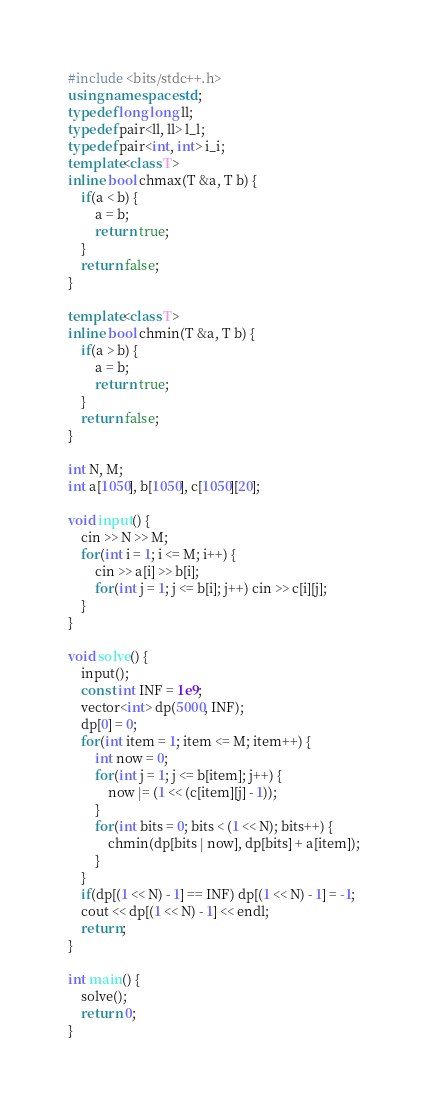Convert code to text. <code><loc_0><loc_0><loc_500><loc_500><_C++_>#include <bits/stdc++.h>
using namespace std;
typedef long long ll;
typedef pair<ll, ll> l_l;
typedef pair<int, int> i_i;
template<class T>
inline bool chmax(T &a, T b) {
    if(a < b) {
        a = b;
        return true;
    }
    return false;
}

template<class T>
inline bool chmin(T &a, T b) {
    if(a > b) {
        a = b;
        return true;
    }
    return false;
}

int N, M;
int a[1050], b[1050], c[1050][20];

void input() {
    cin >> N >> M;
    for(int i = 1; i <= M; i++) {
        cin >> a[i] >> b[i];
        for(int j = 1; j <= b[i]; j++) cin >> c[i][j];
    }
}

void solve() {
    input();
    const int INF = 1e9;
    vector<int> dp(5000, INF);
    dp[0] = 0;
    for(int item = 1; item <= M; item++) {
        int now = 0;
        for(int j = 1; j <= b[item]; j++) {
            now |= (1 << (c[item][j] - 1));
        }
        for(int bits = 0; bits < (1 << N); bits++) {
            chmin(dp[bits | now], dp[bits] + a[item]);
        }
    }
    if(dp[(1 << N) - 1] == INF) dp[(1 << N) - 1] = -1;
    cout << dp[(1 << N) - 1] << endl;
    return;
}

int main() {
    solve();
    return 0;
}
</code> 